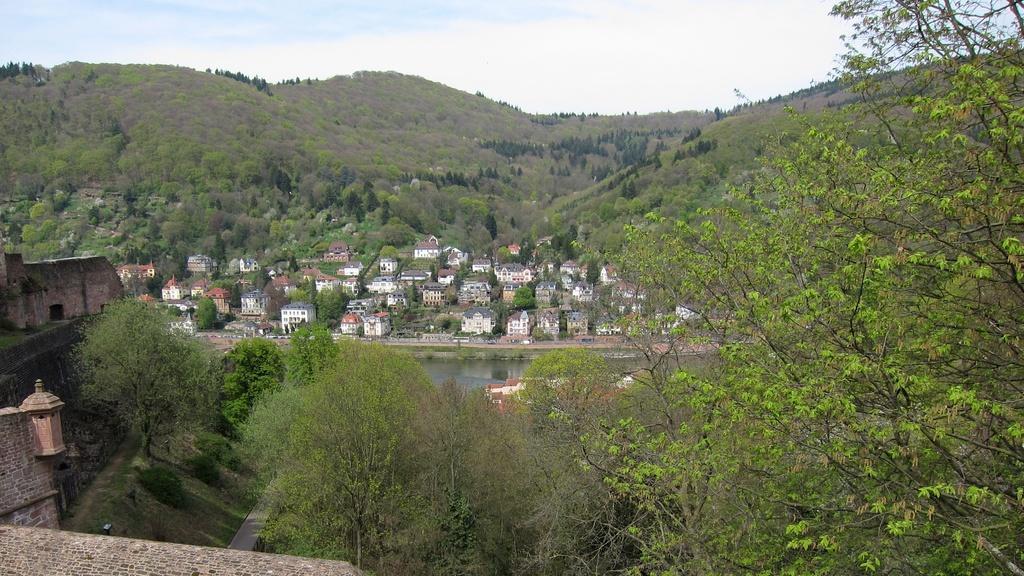Describe this image in one or two sentences. In this image we can see mountains and so many trees. In the middle of the image buildings are present and water body is there. 